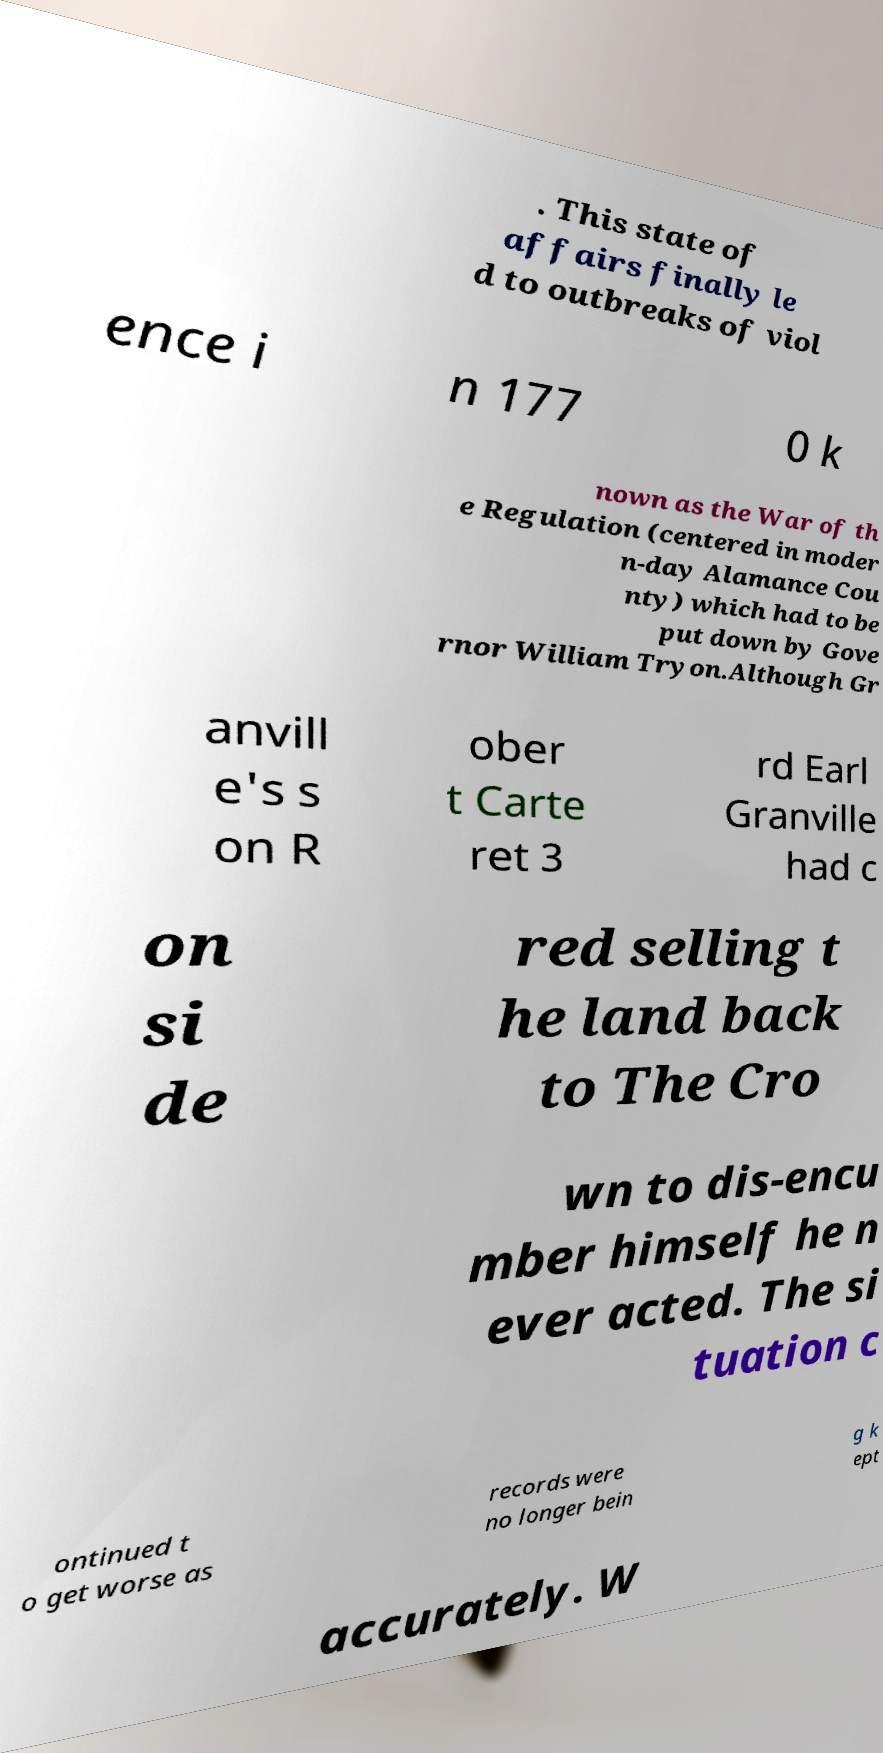Please identify and transcribe the text found in this image. . This state of affairs finally le d to outbreaks of viol ence i n 177 0 k nown as the War of th e Regulation (centered in moder n-day Alamance Cou nty) which had to be put down by Gove rnor William Tryon.Although Gr anvill e's s on R ober t Carte ret 3 rd Earl Granville had c on si de red selling t he land back to The Cro wn to dis-encu mber himself he n ever acted. The si tuation c ontinued t o get worse as records were no longer bein g k ept accurately. W 